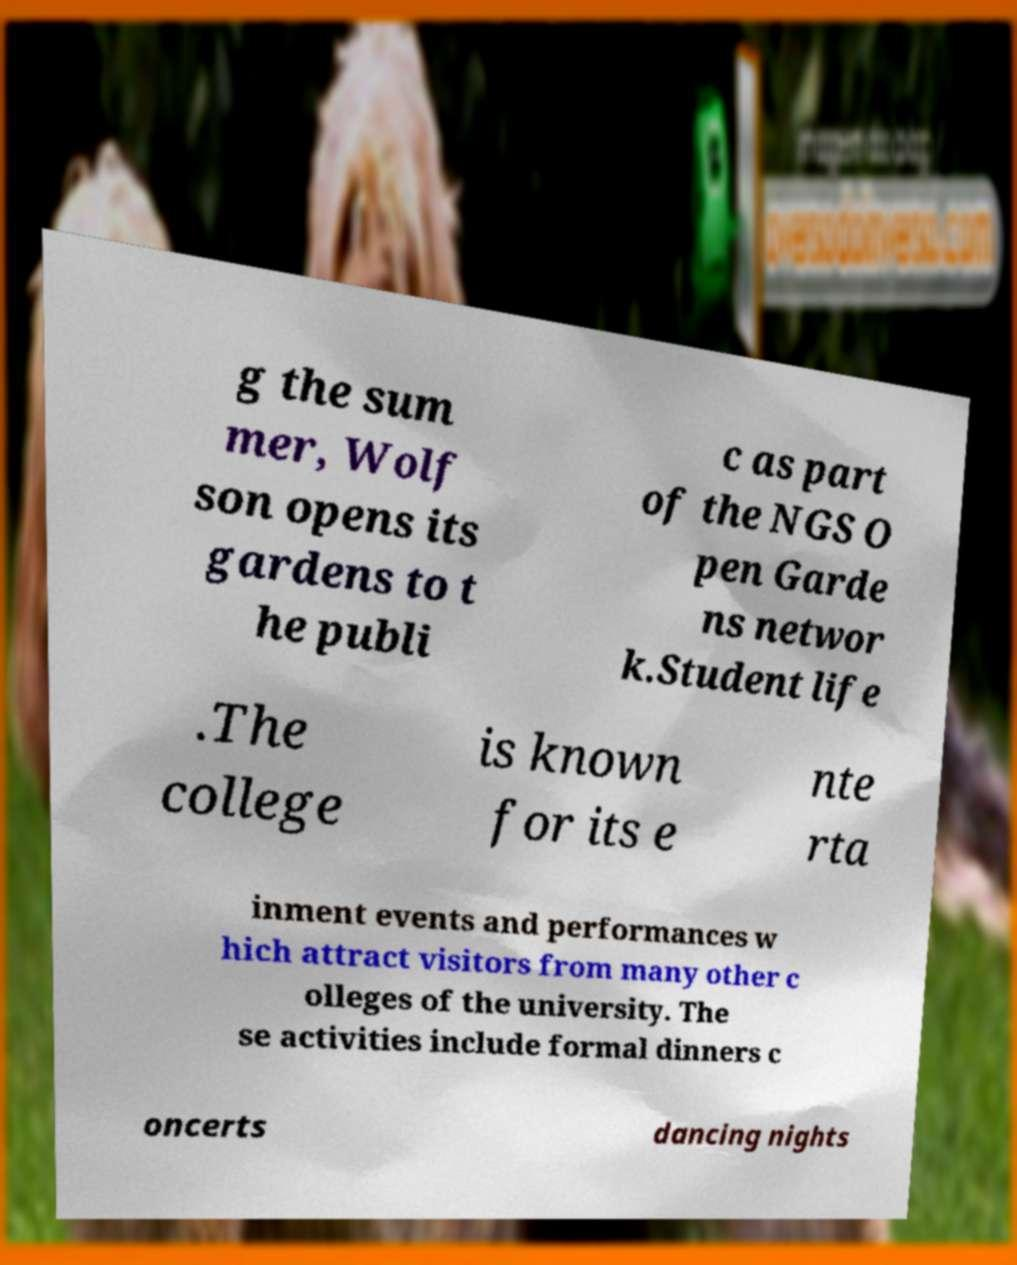Could you extract and type out the text from this image? g the sum mer, Wolf son opens its gardens to t he publi c as part of the NGS O pen Garde ns networ k.Student life .The college is known for its e nte rta inment events and performances w hich attract visitors from many other c olleges of the university. The se activities include formal dinners c oncerts dancing nights 